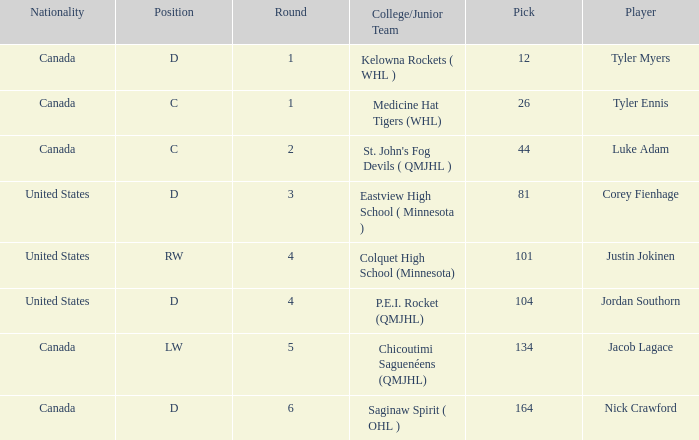What is the average round of the rw position player from the United States? 4.0. 